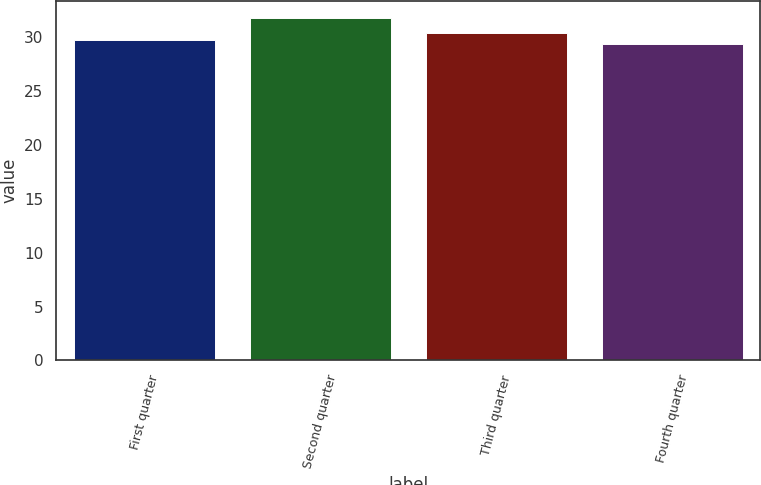Convert chart. <chart><loc_0><loc_0><loc_500><loc_500><bar_chart><fcel>First quarter<fcel>Second quarter<fcel>Third quarter<fcel>Fourth quarter<nl><fcel>29.74<fcel>31.79<fcel>30.41<fcel>29.4<nl></chart> 